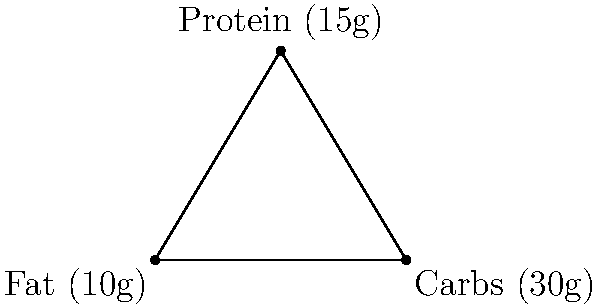A new energy bar recipe is being developed, and its macronutrient content is represented on a coordinate plane. Fat content (10g) is at point (0,0), carbohydrate content (30g) at (6,0), and protein content (15g) at (3,5). Calculate the area of the triangle formed by these three points to determine the balance of macronutrients in the energy bar. Round your answer to the nearest whole number. To find the area of the triangle, we can use the formula:

$$ \text{Area} = \frac{1}{2}|x_1(y_2 - y_3) + x_2(y_3 - y_1) + x_3(y_1 - y_2)| $$

Where $(x_1, y_1)$, $(x_2, y_2)$, and $(x_3, y_3)$ are the coordinates of the three points.

Given:
- Fat (10g): $(0, 0)$
- Carbs (30g): $(6, 0)$
- Protein (15g): $(3, 5)$

Let's substitute these values into the formula:

$$ \begin{align*}
\text{Area} &= \frac{1}{2}|0(0 - 5) + 6(5 - 0) + 3(0 - 0)| \\
&= \frac{1}{2}|0 + 30 + 0| \\
&= \frac{1}{2}(30) \\
&= 15
\end{align*} $$

The area of the triangle is 15 square units.

This area represents the balance of macronutrients in the energy bar. A larger area would indicate a more diverse macronutrient profile, while a smaller area would suggest a more concentrated balance of nutrients.
Answer: 15 square units 